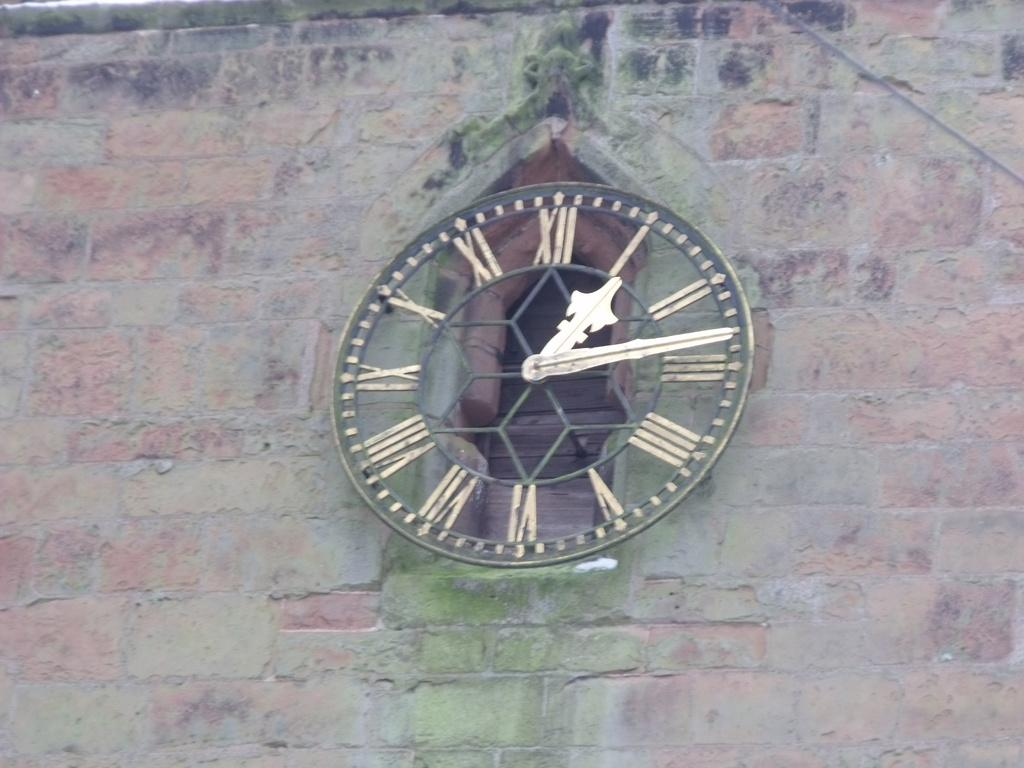What is present on the wall in the image? There is a clock on the wall in the image. Can you describe the clock's location on the wall? The clock is located on the wall, and there is a window behind it. What can be seen through the window in the image? Unfortunately, the facts provided do not mention what can be seen through the window. What type of jam is being spread on the wall in the image? There is no jam or spreading activity present in the image. 